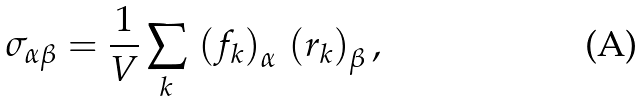Convert formula to latex. <formula><loc_0><loc_0><loc_500><loc_500>\sigma _ { \alpha \beta } = \frac { 1 } { V } \sum _ { k } \, \left ( { f } _ { k } \right ) _ { \alpha } \, \left ( { r } _ { k } \right ) _ { \beta } ,</formula> 